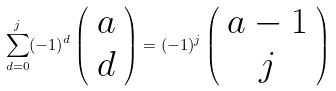<formula> <loc_0><loc_0><loc_500><loc_500>\sum _ { d = 0 } ^ { j } ( - 1 ) ^ { d } \left ( \begin{array} { c c } a \\ d \end{array} \right ) = ( - 1 ) ^ { j } \left ( \begin{array} { c c } a - 1 \\ j \end{array} \right )</formula> 